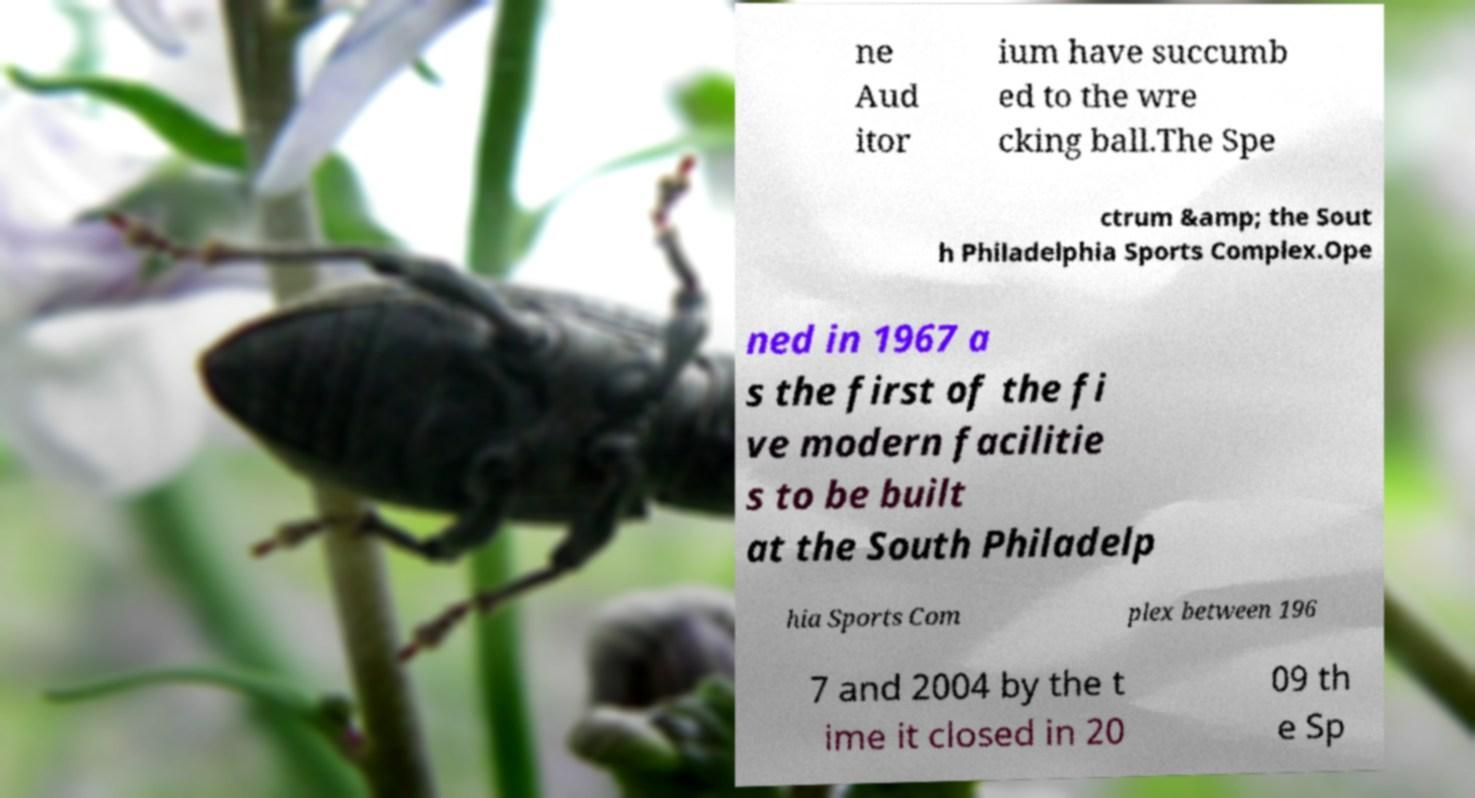Please identify and transcribe the text found in this image. ne Aud itor ium have succumb ed to the wre cking ball.The Spe ctrum &amp; the Sout h Philadelphia Sports Complex.Ope ned in 1967 a s the first of the fi ve modern facilitie s to be built at the South Philadelp hia Sports Com plex between 196 7 and 2004 by the t ime it closed in 20 09 th e Sp 